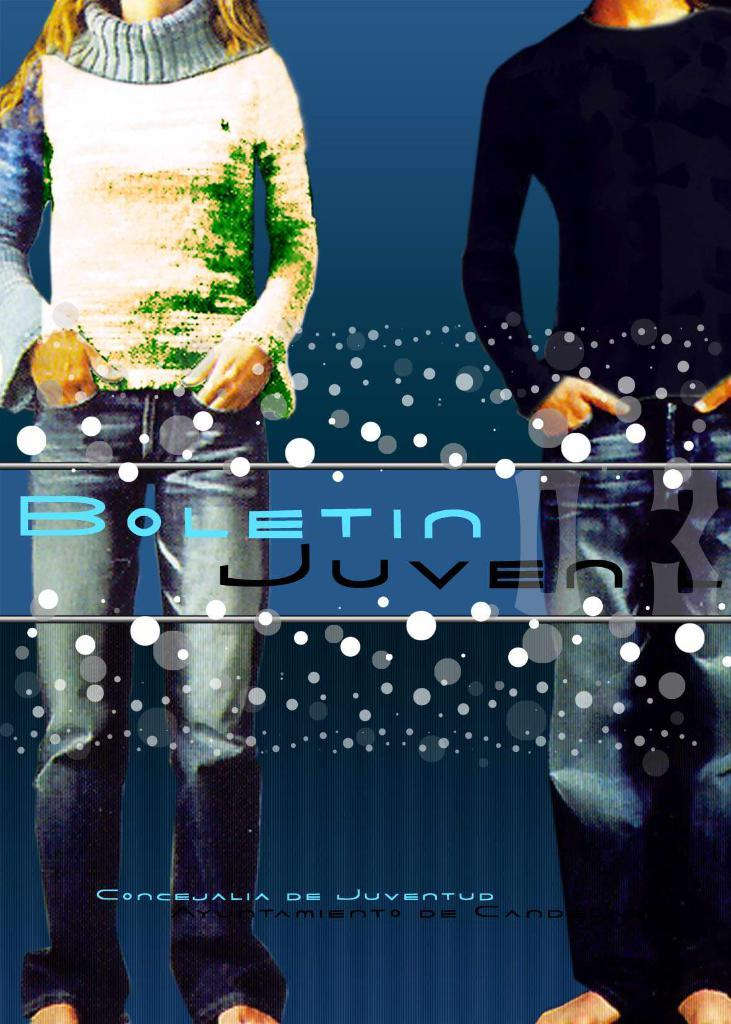What is present in the image? There is a poster in the image. What can be seen in the image on the poster? The poster contains an image of a woman and a man standing. What else is featured on the poster besides the image? There is text on the poster. What type of animal can be seen wishing for a rate in the image? There is no animal present in the image, nor is there any mention of wishing or rates. 